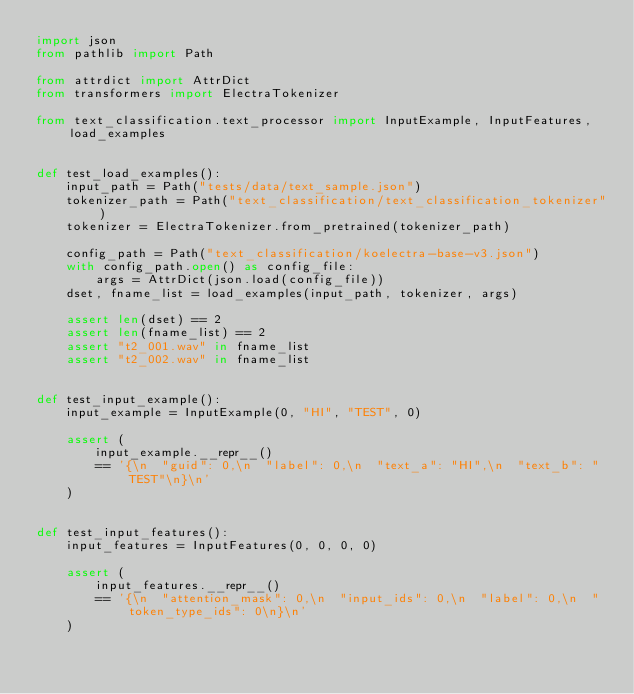<code> <loc_0><loc_0><loc_500><loc_500><_Python_>import json
from pathlib import Path

from attrdict import AttrDict
from transformers import ElectraTokenizer

from text_classification.text_processor import InputExample, InputFeatures, load_examples


def test_load_examples():
    input_path = Path("tests/data/text_sample.json")
    tokenizer_path = Path("text_classification/text_classification_tokenizer")
    tokenizer = ElectraTokenizer.from_pretrained(tokenizer_path)

    config_path = Path("text_classification/koelectra-base-v3.json")
    with config_path.open() as config_file:
        args = AttrDict(json.load(config_file))
    dset, fname_list = load_examples(input_path, tokenizer, args)

    assert len(dset) == 2
    assert len(fname_list) == 2
    assert "t2_001.wav" in fname_list
    assert "t2_002.wav" in fname_list


def test_input_example():
    input_example = InputExample(0, "HI", "TEST", 0)

    assert (
        input_example.__repr__()
        == '{\n  "guid": 0,\n  "label": 0,\n  "text_a": "HI",\n  "text_b": "TEST"\n}\n'
    )


def test_input_features():
    input_features = InputFeatures(0, 0, 0, 0)

    assert (
        input_features.__repr__()
        == '{\n  "attention_mask": 0,\n  "input_ids": 0,\n  "label": 0,\n  "token_type_ids": 0\n}\n'
    )
</code> 